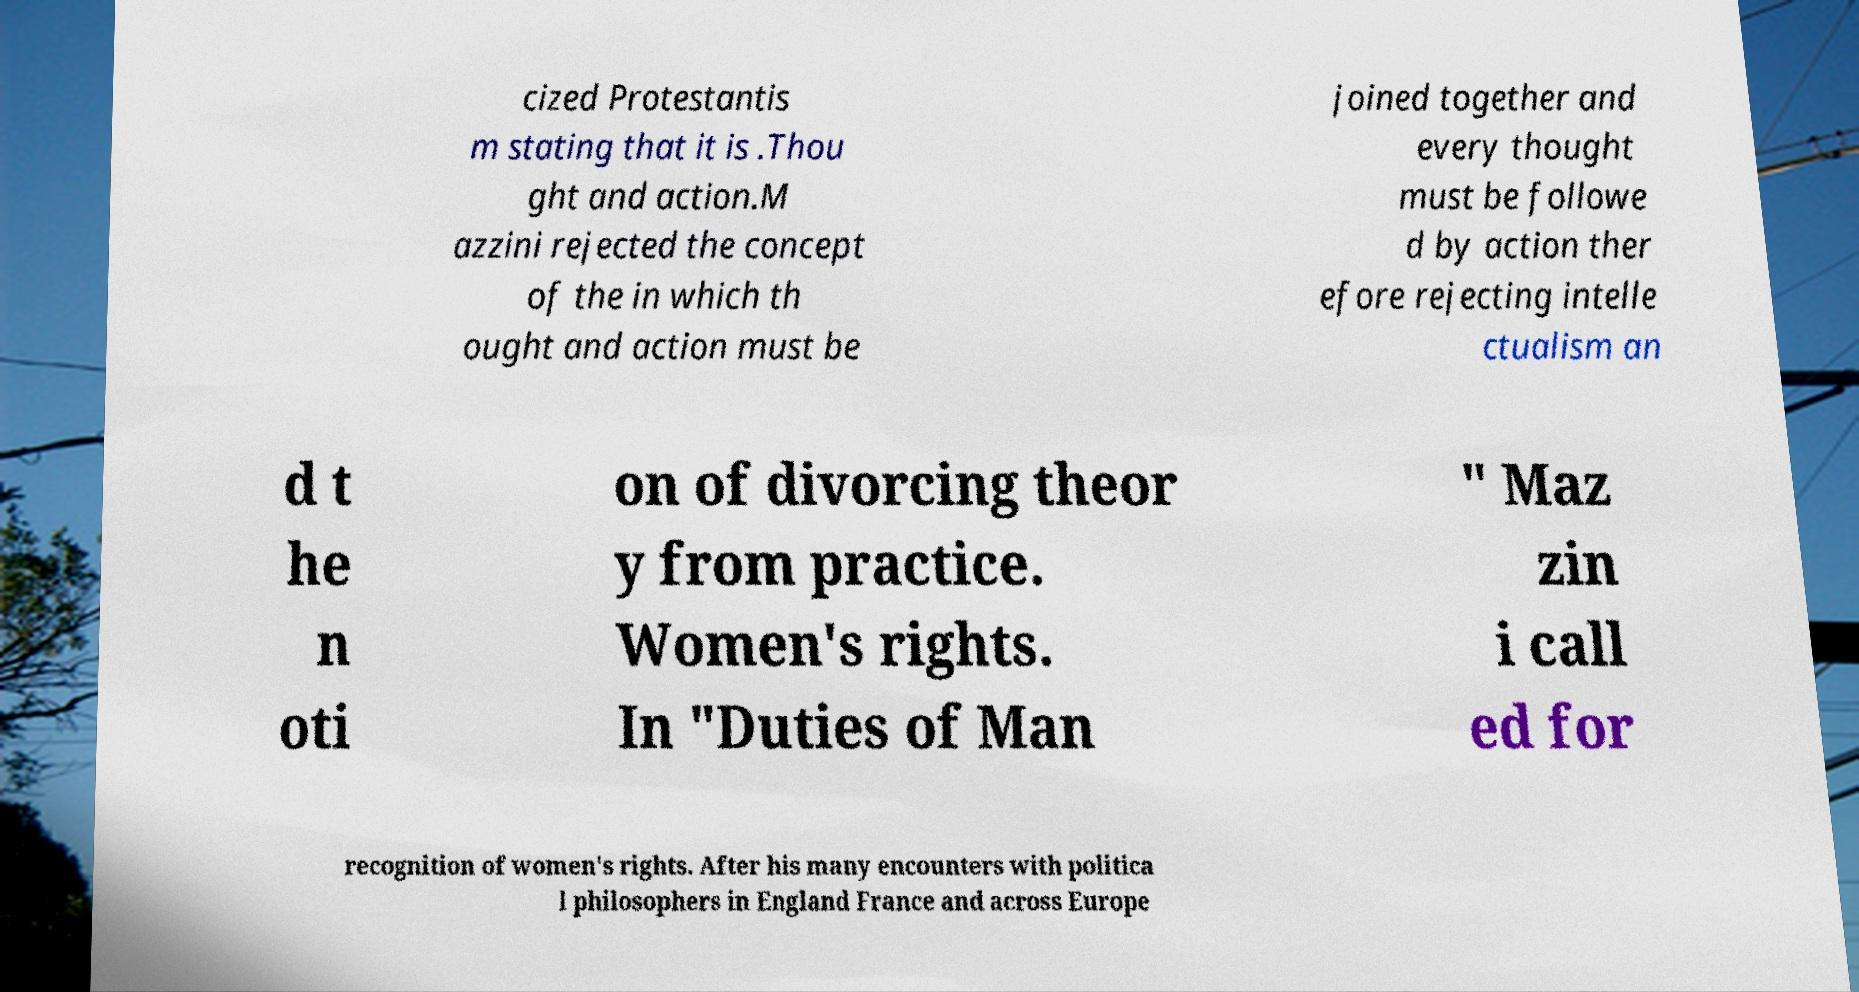Could you assist in decoding the text presented in this image and type it out clearly? cized Protestantis m stating that it is .Thou ght and action.M azzini rejected the concept of the in which th ought and action must be joined together and every thought must be followe d by action ther efore rejecting intelle ctualism an d t he n oti on of divorcing theor y from practice. Women's rights. In "Duties of Man " Maz zin i call ed for recognition of women's rights. After his many encounters with politica l philosophers in England France and across Europe 